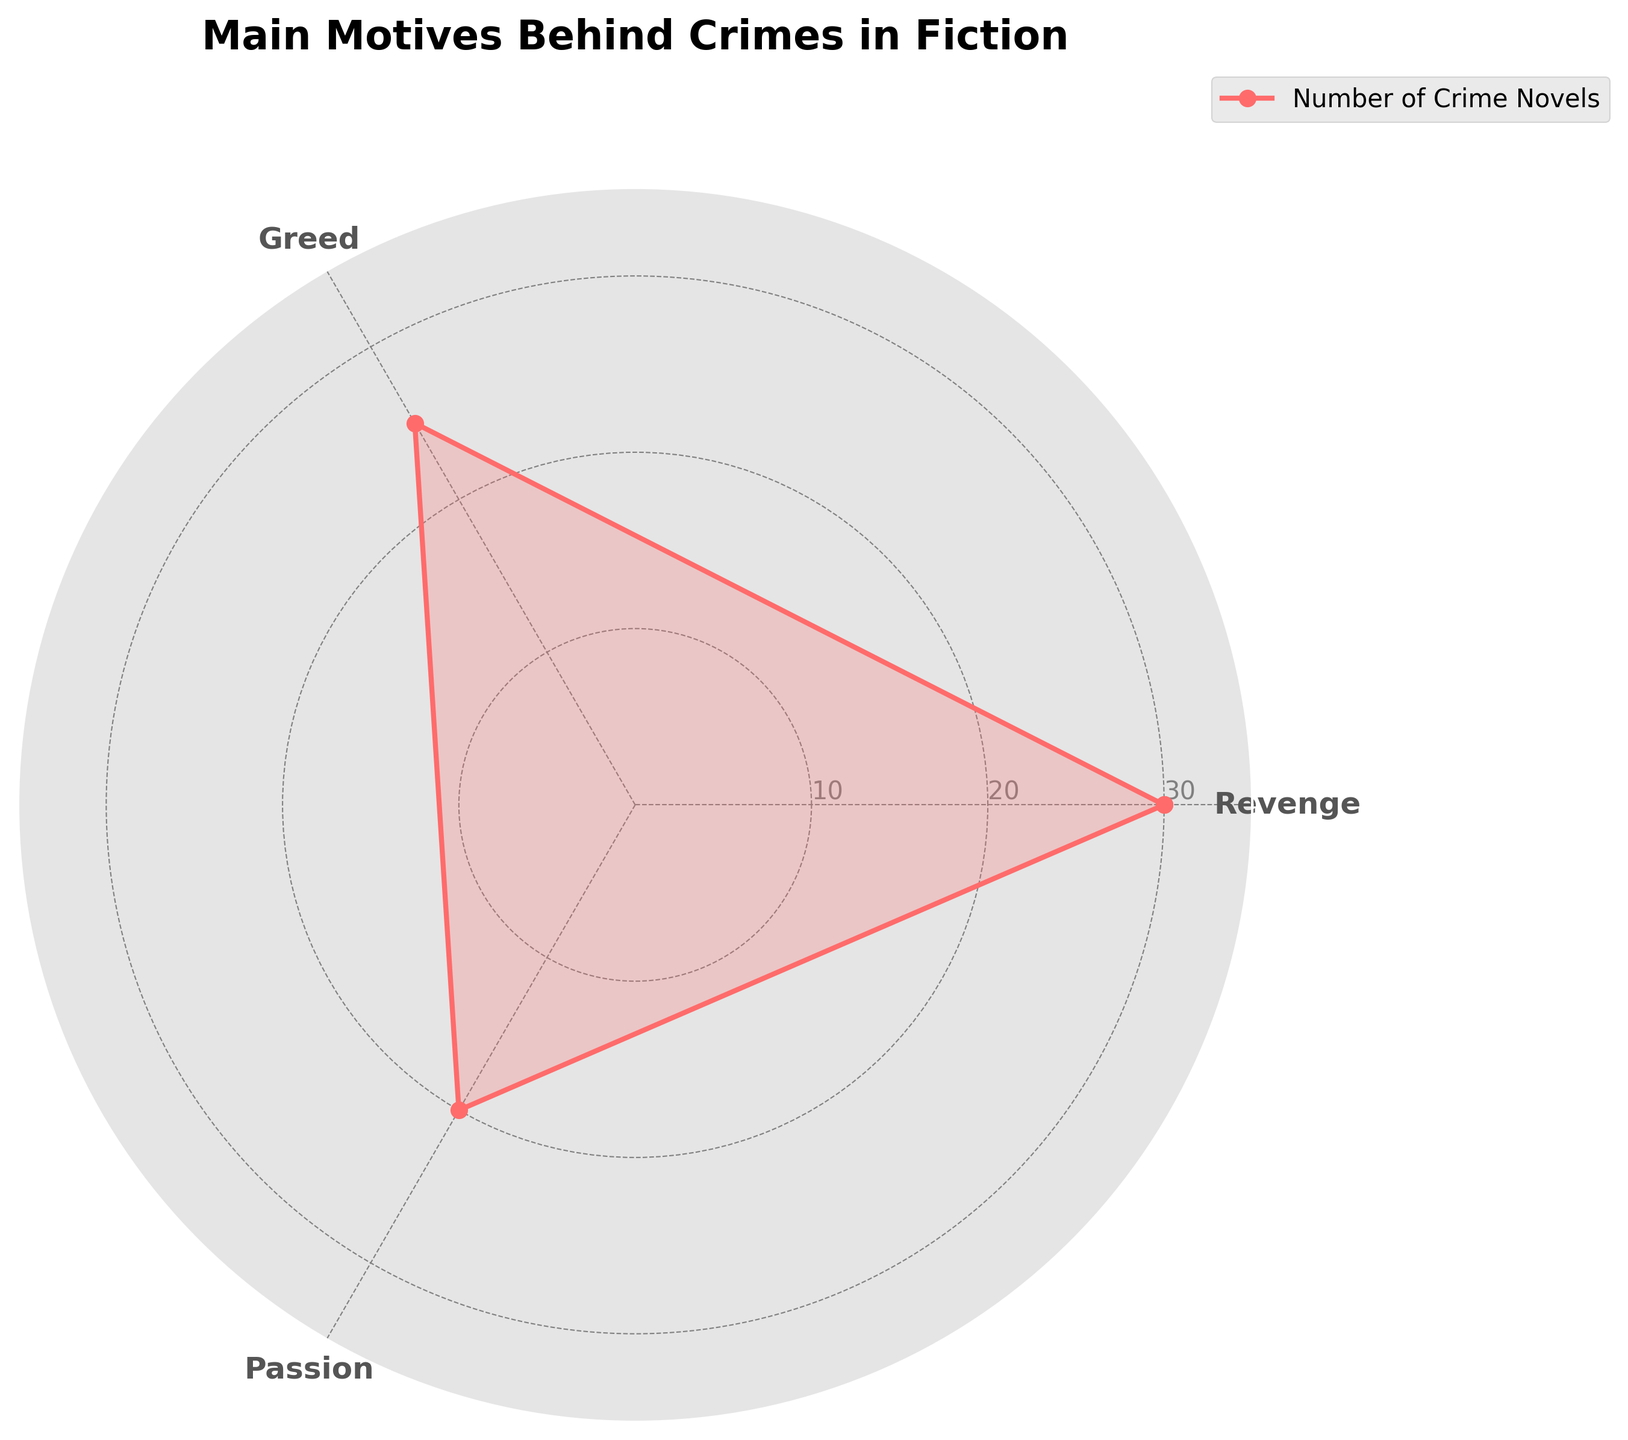What is the title of the radar chart? The title of the radar chart is normally found at the top of the figure. It provides an overview or the main point of the chart.
Answer: Main Motives Behind Crimes in Fiction How many crime motives are displayed in the radar chart? The number of crime motives can be counted by looking at the category labels around the radar chart.
Answer: 3 Which crime motive has the highest number of crime novels? Identify the motive corresponding to the highest point on the radar chart.
Answer: Revenge What is the number of crime novels for the crime motive "Greed"? Locate the point on the chart corresponding to the "Greed" label, and read its value.
Answer: 25 Which crime motive has the lowest number of crime novels? Identify the motive corresponding to the lowest point on the radar chart.
Answer: Passion What is the total number of crime novels for all three motives? Sum the values corresponding to each motive: Revenge, Greed, and Passion. The values are 30, 25, and 20 respectively. The total is 30 + 25 + 20.
Answer: 75 How much higher is the number of crime novels for "Revenge" than for "Passion"? Subtract the number of novels for "Passion" from the number of novels for "Revenge." The values are 30 for "Revenge" and 20 for "Passion." The difference is 30 - 20.
Answer: 10 Arrange the crime motives in descending order based on the number of crime novels. Compare the values for each motive and list them from highest to lowest. The values are 30 for "Revenge," 25 for "Greed," and 20 for "Passion."
Answer: Revenge, Greed, Passion What is the average number of crime novels across the three motives? Sum the values for each motive and divide by the number of motives. The total is 75, and there are 3 motives. The average is 75 / 3.
Answer: 25 If a new crime novel based on "Greed" is added, how would it change the total number of novels and the average? The new total number of novels would be the current total (75) plus 1, making it 76. The new average would be 76 divided by 3.
Answer: Total: 76, Average: 25.33 